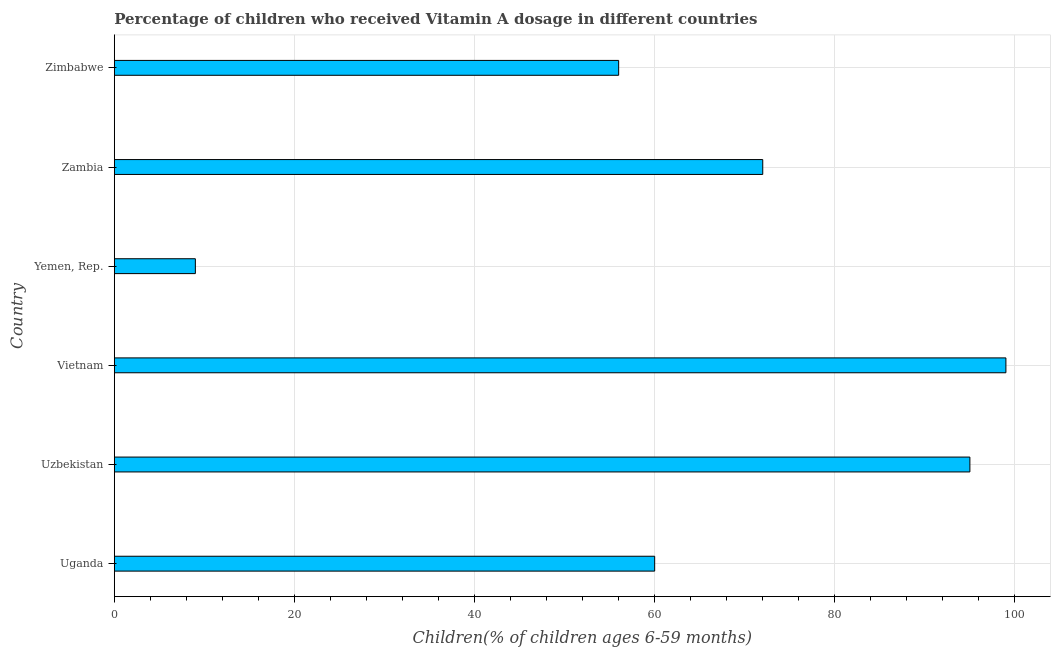What is the title of the graph?
Make the answer very short. Percentage of children who received Vitamin A dosage in different countries. What is the label or title of the X-axis?
Make the answer very short. Children(% of children ages 6-59 months). What is the vitamin a supplementation coverage rate in Vietnam?
Keep it short and to the point. 99. Across all countries, what is the minimum vitamin a supplementation coverage rate?
Offer a very short reply. 9. In which country was the vitamin a supplementation coverage rate maximum?
Your response must be concise. Vietnam. In which country was the vitamin a supplementation coverage rate minimum?
Offer a very short reply. Yemen, Rep. What is the sum of the vitamin a supplementation coverage rate?
Offer a terse response. 391. What is the average vitamin a supplementation coverage rate per country?
Keep it short and to the point. 65.17. What is the ratio of the vitamin a supplementation coverage rate in Uganda to that in Uzbekistan?
Offer a terse response. 0.63. Is the difference between the vitamin a supplementation coverage rate in Vietnam and Yemen, Rep. greater than the difference between any two countries?
Your response must be concise. Yes. Is the sum of the vitamin a supplementation coverage rate in Uganda and Zimbabwe greater than the maximum vitamin a supplementation coverage rate across all countries?
Provide a succinct answer. Yes. What is the difference between the highest and the lowest vitamin a supplementation coverage rate?
Offer a very short reply. 90. Are all the bars in the graph horizontal?
Ensure brevity in your answer.  Yes. How many countries are there in the graph?
Your response must be concise. 6. What is the difference between two consecutive major ticks on the X-axis?
Your response must be concise. 20. What is the Children(% of children ages 6-59 months) in Uganda?
Your answer should be very brief. 60. What is the Children(% of children ages 6-59 months) of Vietnam?
Your answer should be very brief. 99. What is the Children(% of children ages 6-59 months) in Yemen, Rep.?
Your answer should be compact. 9. What is the Children(% of children ages 6-59 months) in Zimbabwe?
Your response must be concise. 56. What is the difference between the Children(% of children ages 6-59 months) in Uganda and Uzbekistan?
Ensure brevity in your answer.  -35. What is the difference between the Children(% of children ages 6-59 months) in Uganda and Vietnam?
Give a very brief answer. -39. What is the difference between the Children(% of children ages 6-59 months) in Uzbekistan and Yemen, Rep.?
Your response must be concise. 86. What is the difference between the Children(% of children ages 6-59 months) in Vietnam and Zimbabwe?
Keep it short and to the point. 43. What is the difference between the Children(% of children ages 6-59 months) in Yemen, Rep. and Zambia?
Provide a succinct answer. -63. What is the difference between the Children(% of children ages 6-59 months) in Yemen, Rep. and Zimbabwe?
Make the answer very short. -47. What is the ratio of the Children(% of children ages 6-59 months) in Uganda to that in Uzbekistan?
Give a very brief answer. 0.63. What is the ratio of the Children(% of children ages 6-59 months) in Uganda to that in Vietnam?
Ensure brevity in your answer.  0.61. What is the ratio of the Children(% of children ages 6-59 months) in Uganda to that in Yemen, Rep.?
Provide a short and direct response. 6.67. What is the ratio of the Children(% of children ages 6-59 months) in Uganda to that in Zambia?
Your answer should be compact. 0.83. What is the ratio of the Children(% of children ages 6-59 months) in Uganda to that in Zimbabwe?
Offer a terse response. 1.07. What is the ratio of the Children(% of children ages 6-59 months) in Uzbekistan to that in Yemen, Rep.?
Offer a very short reply. 10.56. What is the ratio of the Children(% of children ages 6-59 months) in Uzbekistan to that in Zambia?
Offer a very short reply. 1.32. What is the ratio of the Children(% of children ages 6-59 months) in Uzbekistan to that in Zimbabwe?
Make the answer very short. 1.7. What is the ratio of the Children(% of children ages 6-59 months) in Vietnam to that in Yemen, Rep.?
Offer a terse response. 11. What is the ratio of the Children(% of children ages 6-59 months) in Vietnam to that in Zambia?
Your answer should be compact. 1.38. What is the ratio of the Children(% of children ages 6-59 months) in Vietnam to that in Zimbabwe?
Offer a terse response. 1.77. What is the ratio of the Children(% of children ages 6-59 months) in Yemen, Rep. to that in Zimbabwe?
Keep it short and to the point. 0.16. What is the ratio of the Children(% of children ages 6-59 months) in Zambia to that in Zimbabwe?
Your response must be concise. 1.29. 